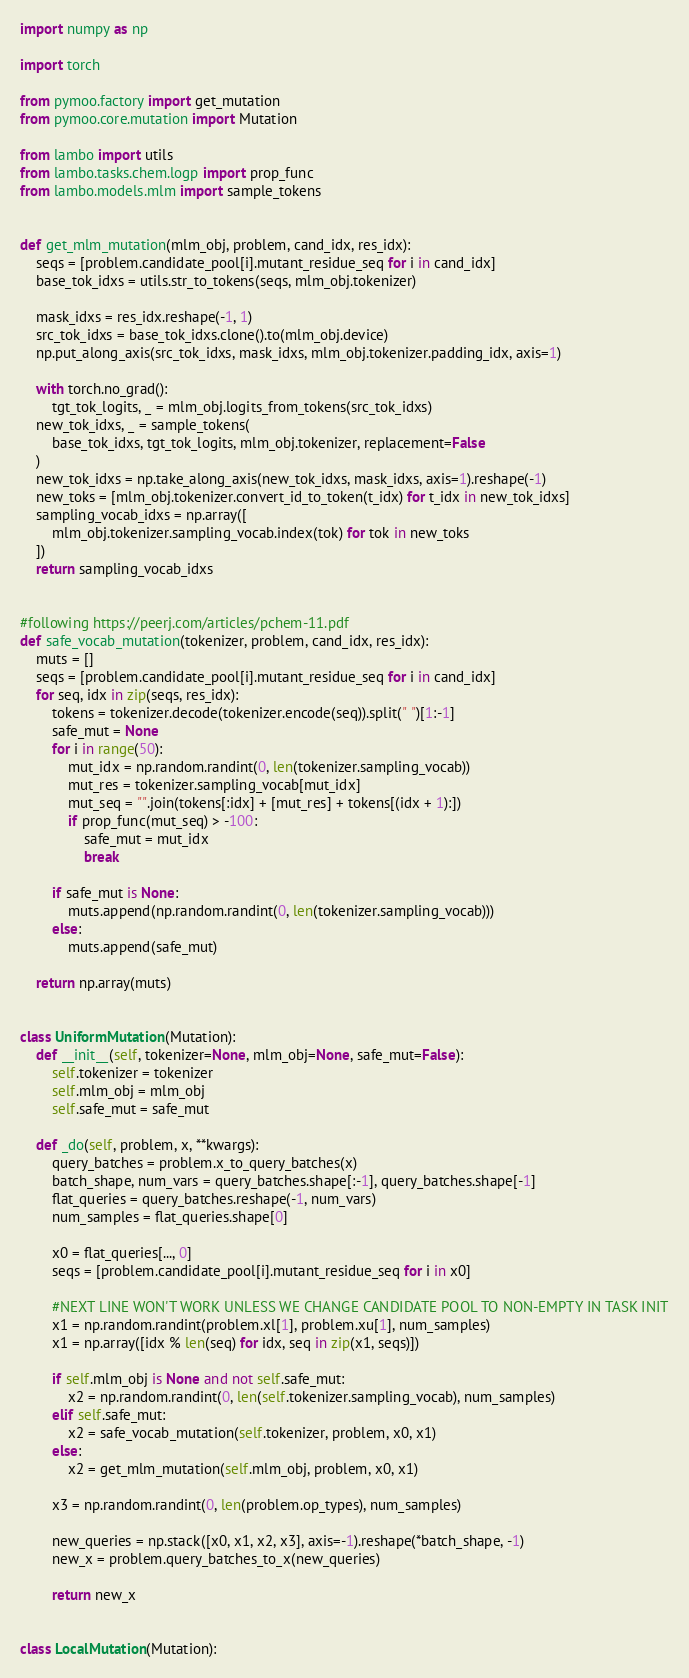<code> <loc_0><loc_0><loc_500><loc_500><_Python_>import numpy as np

import torch

from pymoo.factory import get_mutation
from pymoo.core.mutation import Mutation

from lambo import utils
from lambo.tasks.chem.logp import prop_func
from lambo.models.mlm import sample_tokens


def get_mlm_mutation(mlm_obj, problem, cand_idx, res_idx):
    seqs = [problem.candidate_pool[i].mutant_residue_seq for i in cand_idx]
    base_tok_idxs = utils.str_to_tokens(seqs, mlm_obj.tokenizer)

    mask_idxs = res_idx.reshape(-1, 1)
    src_tok_idxs = base_tok_idxs.clone().to(mlm_obj.device)
    np.put_along_axis(src_tok_idxs, mask_idxs, mlm_obj.tokenizer.padding_idx, axis=1)

    with torch.no_grad():
        tgt_tok_logits, _ = mlm_obj.logits_from_tokens(src_tok_idxs)
    new_tok_idxs, _ = sample_tokens(
        base_tok_idxs, tgt_tok_logits, mlm_obj.tokenizer, replacement=False
    )
    new_tok_idxs = np.take_along_axis(new_tok_idxs, mask_idxs, axis=1).reshape(-1)
    new_toks = [mlm_obj.tokenizer.convert_id_to_token(t_idx) for t_idx in new_tok_idxs]
    sampling_vocab_idxs = np.array([
        mlm_obj.tokenizer.sampling_vocab.index(tok) for tok in new_toks
    ])
    return sampling_vocab_idxs


#following https://peerj.com/articles/pchem-11.pdf
def safe_vocab_mutation(tokenizer, problem, cand_idx, res_idx):
    muts = []
    seqs = [problem.candidate_pool[i].mutant_residue_seq for i in cand_idx]
    for seq, idx in zip(seqs, res_idx):
        tokens = tokenizer.decode(tokenizer.encode(seq)).split(" ")[1:-1]
        safe_mut = None
        for i in range(50):
            mut_idx = np.random.randint(0, len(tokenizer.sampling_vocab))
            mut_res = tokenizer.sampling_vocab[mut_idx]
            mut_seq = "".join(tokens[:idx] + [mut_res] + tokens[(idx + 1):])
            if prop_func(mut_seq) > -100:
                safe_mut = mut_idx
                break

        if safe_mut is None:
            muts.append(np.random.randint(0, len(tokenizer.sampling_vocab)))
        else:
            muts.append(safe_mut)

    return np.array(muts)


class UniformMutation(Mutation):
    def __init__(self, tokenizer=None, mlm_obj=None, safe_mut=False):
        self.tokenizer = tokenizer
        self.mlm_obj = mlm_obj
        self.safe_mut = safe_mut

    def _do(self, problem, x, **kwargs):
        query_batches = problem.x_to_query_batches(x)
        batch_shape, num_vars = query_batches.shape[:-1], query_batches.shape[-1]
        flat_queries = query_batches.reshape(-1, num_vars)
        num_samples = flat_queries.shape[0]

        x0 = flat_queries[..., 0]
        seqs = [problem.candidate_pool[i].mutant_residue_seq for i in x0]

        #NEXT LINE WON'T WORK UNLESS WE CHANGE CANDIDATE POOL TO NON-EMPTY IN TASK INIT
        x1 = np.random.randint(problem.xl[1], problem.xu[1], num_samples)
        x1 = np.array([idx % len(seq) for idx, seq in zip(x1, seqs)])

        if self.mlm_obj is None and not self.safe_mut:
            x2 = np.random.randint(0, len(self.tokenizer.sampling_vocab), num_samples)
        elif self.safe_mut:
            x2 = safe_vocab_mutation(self.tokenizer, problem, x0, x1)
        else:
            x2 = get_mlm_mutation(self.mlm_obj, problem, x0, x1)

        x3 = np.random.randint(0, len(problem.op_types), num_samples)

        new_queries = np.stack([x0, x1, x2, x3], axis=-1).reshape(*batch_shape, -1)
        new_x = problem.query_batches_to_x(new_queries)

        return new_x


class LocalMutation(Mutation):</code> 